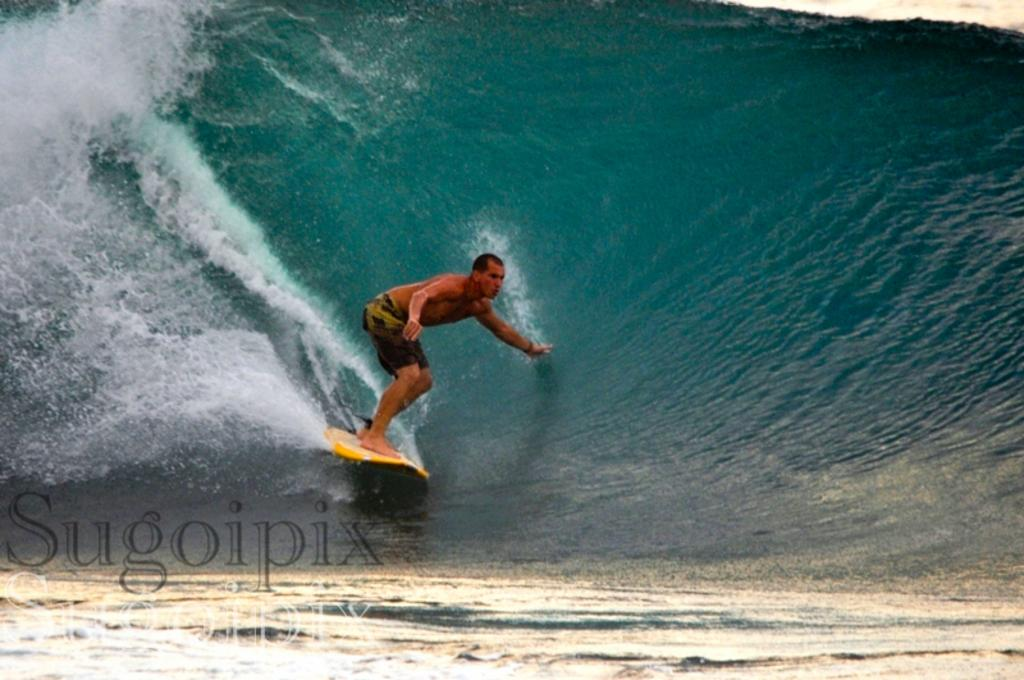What is the main subject of the image? There is a person in the image. What is the person doing in the image? The person is on a surfboard. What is the surfboard resting on? The surfboard is on the water. What color is the surfboard? The surfboard is yellow. How many toes can be seen on the person's foot in the image? The image does not show the person's toes, so it cannot be determined from the image. 